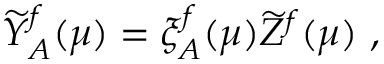<formula> <loc_0><loc_0><loc_500><loc_500>\widetilde { Y } _ { A } ^ { f } ( \mu ) = \xi _ { A } ^ { f } ( \mu ) \widetilde { Z } ^ { f } ( \mu ) \ ,</formula> 